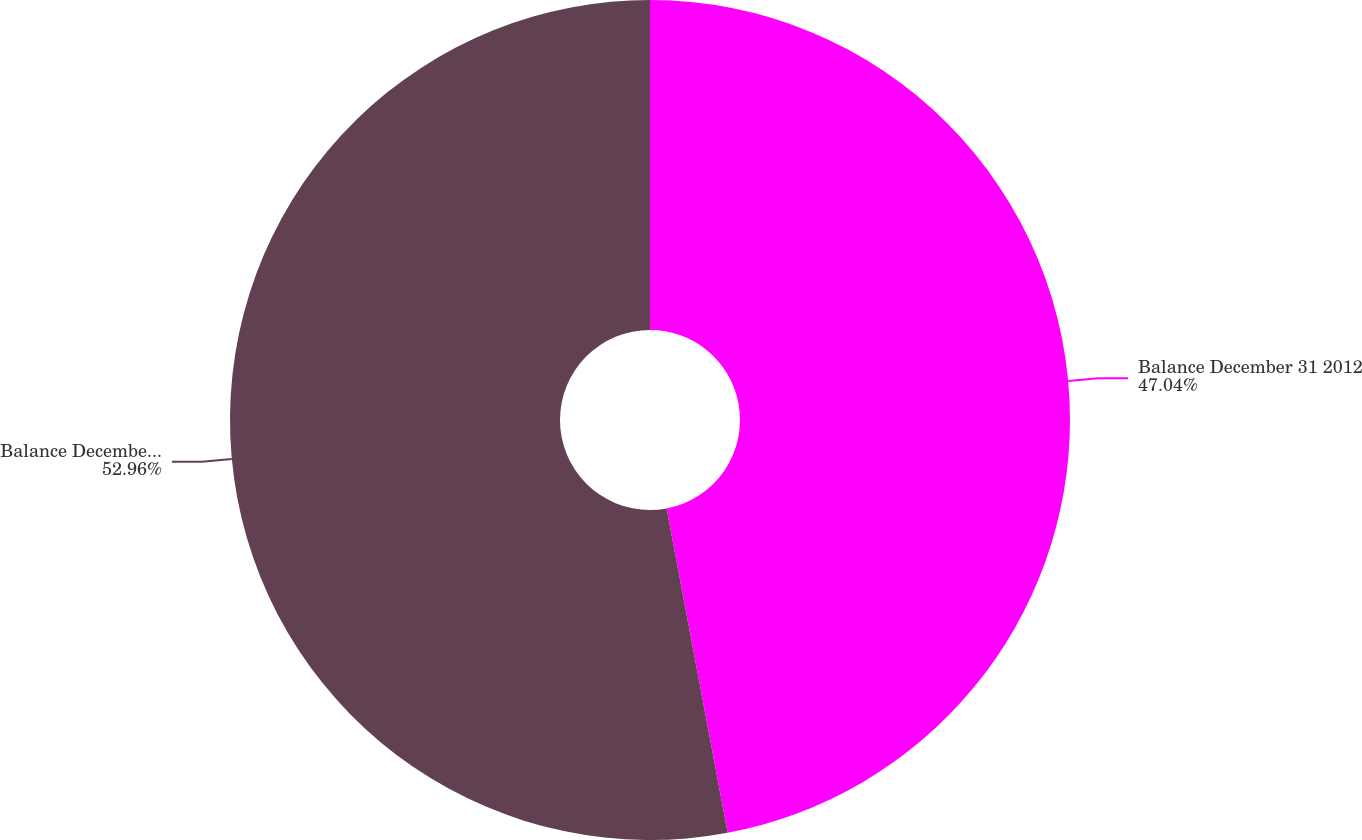Convert chart to OTSL. <chart><loc_0><loc_0><loc_500><loc_500><pie_chart><fcel>Balance December 31 2012<fcel>Balance December 31 2013<nl><fcel>47.04%<fcel>52.96%<nl></chart> 